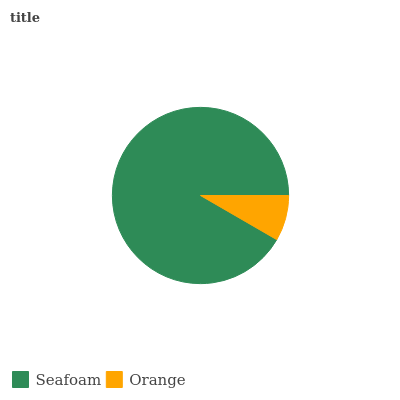Is Orange the minimum?
Answer yes or no. Yes. Is Seafoam the maximum?
Answer yes or no. Yes. Is Orange the maximum?
Answer yes or no. No. Is Seafoam greater than Orange?
Answer yes or no. Yes. Is Orange less than Seafoam?
Answer yes or no. Yes. Is Orange greater than Seafoam?
Answer yes or no. No. Is Seafoam less than Orange?
Answer yes or no. No. Is Seafoam the high median?
Answer yes or no. Yes. Is Orange the low median?
Answer yes or no. Yes. Is Orange the high median?
Answer yes or no. No. Is Seafoam the low median?
Answer yes or no. No. 